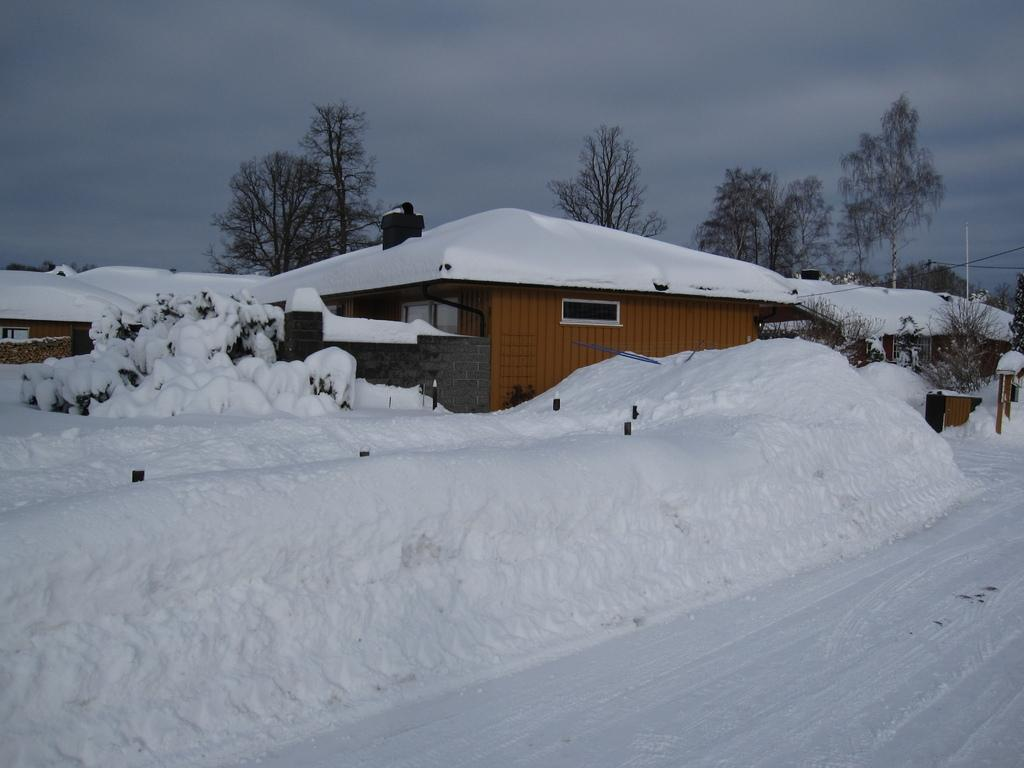What is covering the ground in the image? The ground in the image is covered with snow. What structures can be seen in the image? There are buildings and houses in the image. What can be seen in the background of the image? Trees and houses are visible in the background of the image. How are the houses in the image affected by the snow? The houses in the image are covered with snow. What is the condition of the sky in the image? The sky in the image is cloudy. How many kittens are giving advice to the trees in the image? There are no kittens present in the image, and therefore no such activity can be observed. 